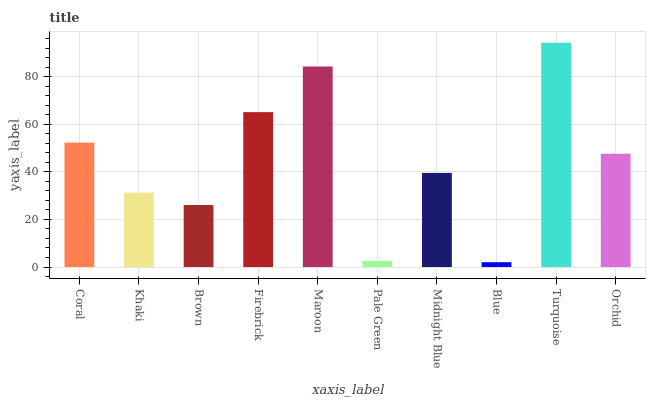Is Khaki the minimum?
Answer yes or no. No. Is Khaki the maximum?
Answer yes or no. No. Is Coral greater than Khaki?
Answer yes or no. Yes. Is Khaki less than Coral?
Answer yes or no. Yes. Is Khaki greater than Coral?
Answer yes or no. No. Is Coral less than Khaki?
Answer yes or no. No. Is Orchid the high median?
Answer yes or no. Yes. Is Midnight Blue the low median?
Answer yes or no. Yes. Is Maroon the high median?
Answer yes or no. No. Is Pale Green the low median?
Answer yes or no. No. 